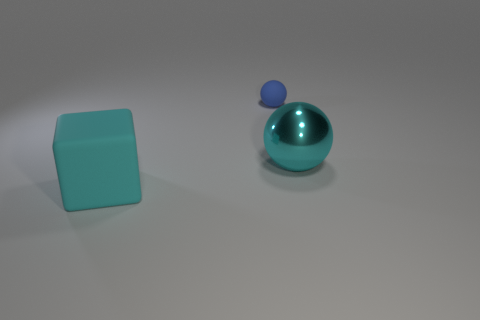Are there any other things that have the same size as the rubber ball?
Your answer should be very brief. No. Does the big cyan thing behind the big cyan rubber object have the same shape as the tiny blue object?
Provide a short and direct response. Yes. The large shiny sphere is what color?
Ensure brevity in your answer.  Cyan. What is the color of the tiny rubber object that is the same shape as the cyan metallic object?
Provide a short and direct response. Blue. What number of tiny matte things have the same shape as the large cyan metal thing?
Your answer should be very brief. 1. What number of objects are big blocks or cyan rubber objects that are in front of the matte ball?
Provide a short and direct response. 1. Does the large ball have the same color as the large object that is in front of the big cyan ball?
Your answer should be very brief. Yes. There is a object that is behind the big matte cube and left of the cyan ball; what is its size?
Provide a succinct answer. Small. Are there any large blocks in front of the small blue matte object?
Provide a succinct answer. Yes. Are there any matte things that are to the right of the object that is in front of the cyan ball?
Ensure brevity in your answer.  Yes. 